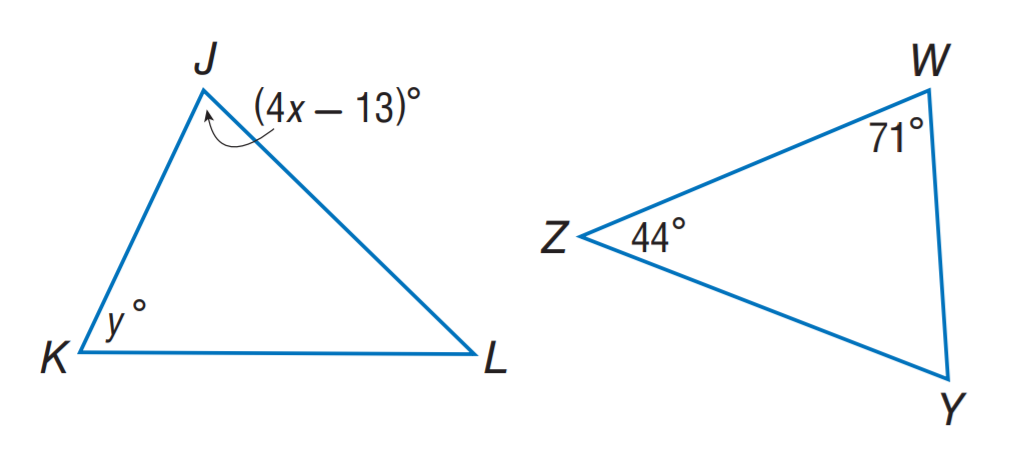Answer the mathemtical geometry problem and directly provide the correct option letter.
Question: \triangle J K L \sim \triangle W Y Z. Find y.
Choices: A: 44 B: 56 C: 65 D: 71 C 